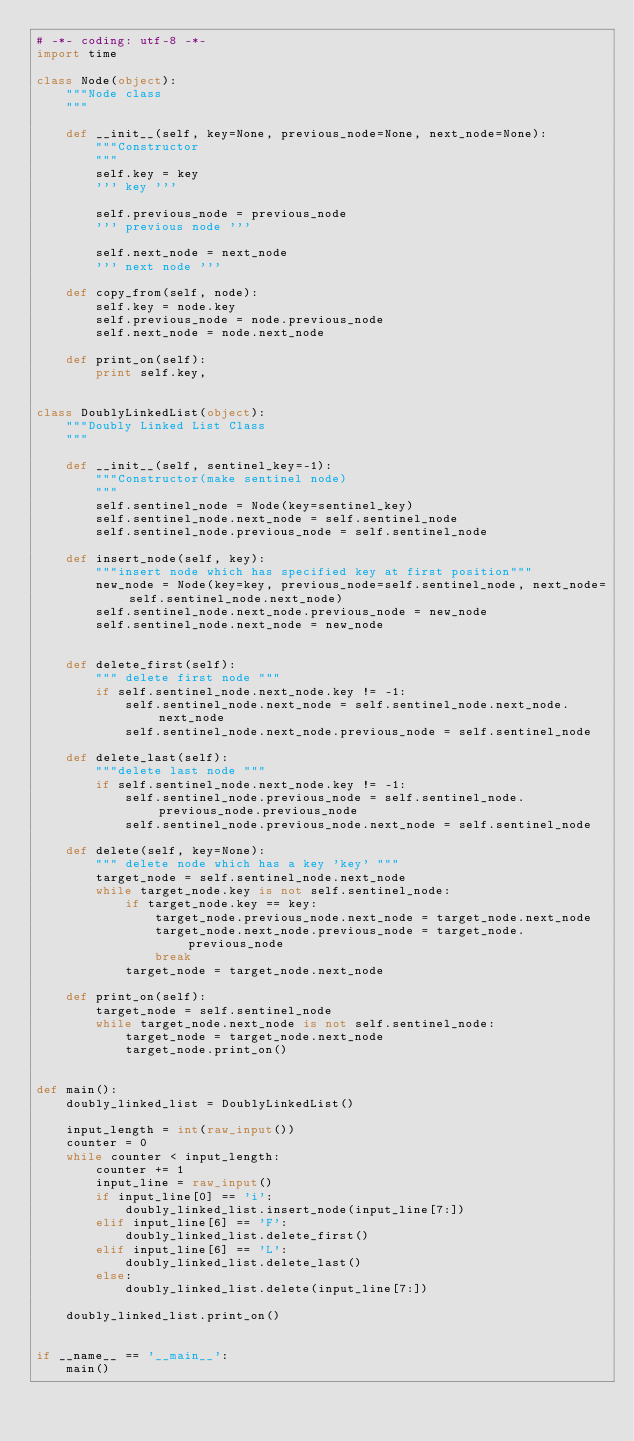<code> <loc_0><loc_0><loc_500><loc_500><_Python_># -*- coding: utf-8 -*-
import time 

class Node(object):
    """Node class
    """

    def __init__(self, key=None, previous_node=None, next_node=None):
        """Constructor
        """
        self.key = key
        ''' key '''

        self.previous_node = previous_node
        ''' previous node '''

        self.next_node = next_node
        ''' next node '''

    def copy_from(self, node):
        self.key = node.key
        self.previous_node = node.previous_node
        self.next_node = node.next_node

    def print_on(self):
        print self.key, 


class DoublyLinkedList(object):
    """Doubly Linked List Class
    """

    def __init__(self, sentinel_key=-1):
        """Constructor(make sentinel node)
        """
        self.sentinel_node = Node(key=sentinel_key)
        self.sentinel_node.next_node = self.sentinel_node
        self.sentinel_node.previous_node = self.sentinel_node

    def insert_node(self, key):
        """insert node which has specified key at first position"""
        new_node = Node(key=key, previous_node=self.sentinel_node, next_node=self.sentinel_node.next_node) 
        self.sentinel_node.next_node.previous_node = new_node
        self.sentinel_node.next_node = new_node


    def delete_first(self):
        """ delete first node """
        if self.sentinel_node.next_node.key != -1:
            self.sentinel_node.next_node = self.sentinel_node.next_node.next_node
            self.sentinel_node.next_node.previous_node = self.sentinel_node

    def delete_last(self):
        """delete last node """
        if self.sentinel_node.next_node.key != -1:
            self.sentinel_node.previous_node = self.sentinel_node.previous_node.previous_node
            self.sentinel_node.previous_node.next_node = self.sentinel_node
 
    def delete(self, key=None):
        """ delete node which has a key 'key' """
        target_node = self.sentinel_node.next_node
        while target_node.key is not self.sentinel_node:
            if target_node.key == key:
                target_node.previous_node.next_node = target_node.next_node
                target_node.next_node.previous_node = target_node.previous_node
                break
            target_node = target_node.next_node
 
    def print_on(self):
        target_node = self.sentinel_node
        while target_node.next_node is not self.sentinel_node:
            target_node = target_node.next_node
            target_node.print_on()
            

def main():
    doubly_linked_list = DoublyLinkedList()

    input_length = int(raw_input())
    counter = 0
    while counter < input_length:
        counter += 1
        input_line = raw_input()
        if input_line[0] == 'i':
            doubly_linked_list.insert_node(input_line[7:])
        elif input_line[6] == 'F':
            doubly_linked_list.delete_first()
        elif input_line[6] == 'L':
            doubly_linked_list.delete_last()
        else:
            doubly_linked_list.delete(input_line[7:])

    doubly_linked_list.print_on()


if __name__ == '__main__':
    main()</code> 